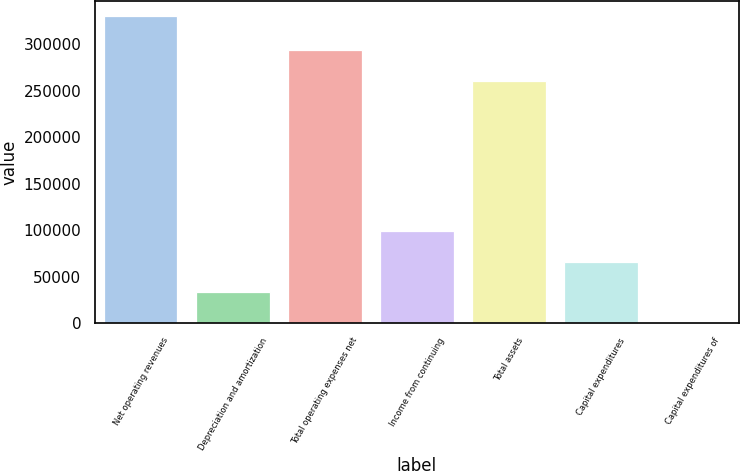Convert chart to OTSL. <chart><loc_0><loc_0><loc_500><loc_500><bar_chart><fcel>Net operating revenues<fcel>Depreciation and amortization<fcel>Total operating expenses net<fcel>Income from continuing<fcel>Total assets<fcel>Capital expenditures<fcel>Capital expenditures of<nl><fcel>330329<fcel>33034.9<fcel>293288<fcel>99100.3<fcel>260255<fcel>66067.6<fcel>2.26<nl></chart> 